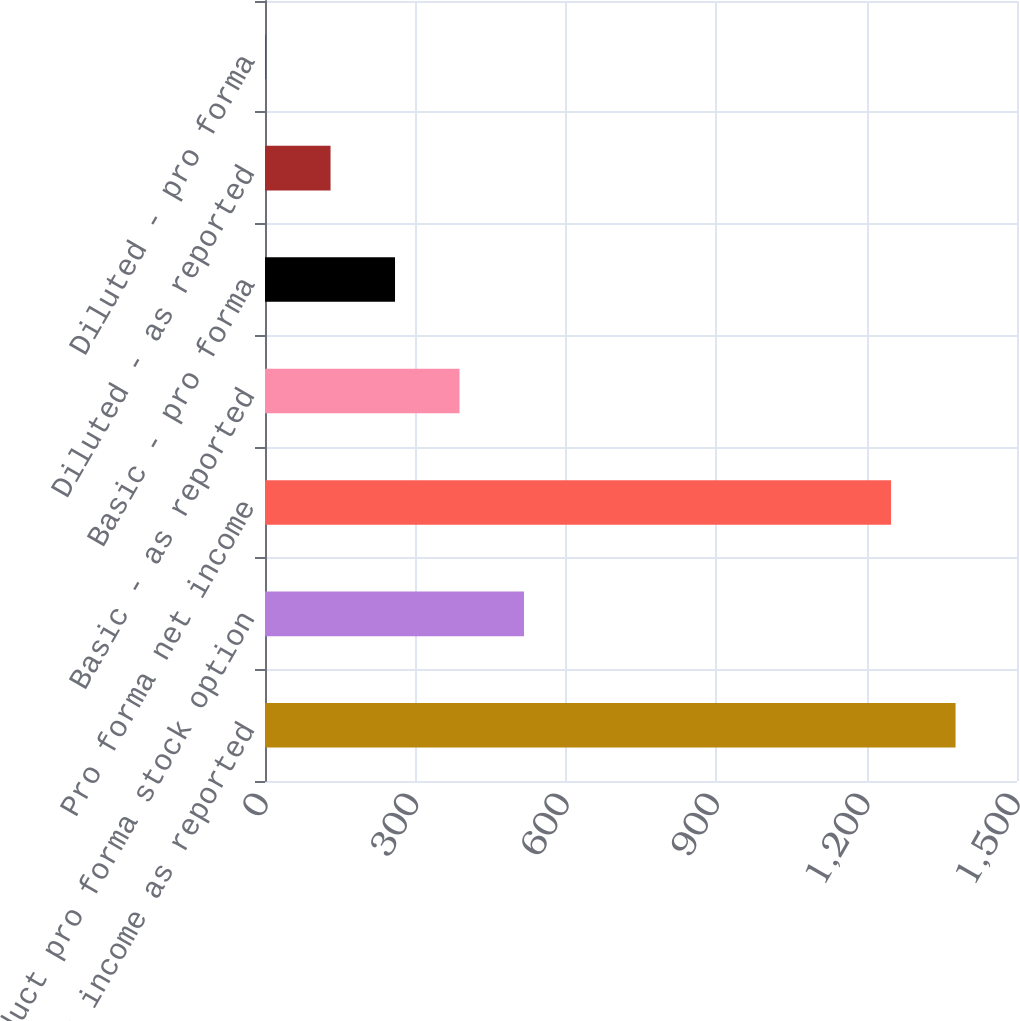Convert chart to OTSL. <chart><loc_0><loc_0><loc_500><loc_500><bar_chart><fcel>Net income as reported<fcel>Deduct pro forma stock option<fcel>Pro forma net income<fcel>Basic - as reported<fcel>Basic - pro forma<fcel>Diluted - as reported<fcel>Diluted - pro forma<nl><fcel>1377.42<fcel>516.6<fcel>1248.8<fcel>387.98<fcel>259.36<fcel>130.74<fcel>2.12<nl></chart> 